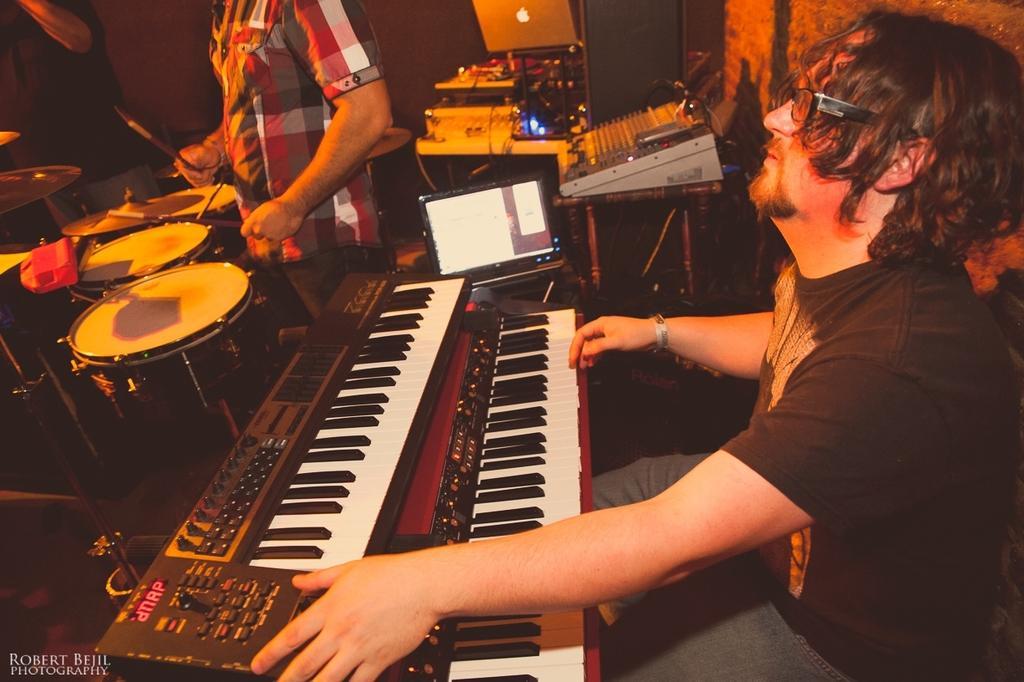Could you give a brief overview of what you see in this image? This is a picture taken in a room, the man in black t shirt sitting on a chair and playing the piano and the other man is holding a drum stick and playing the drum. Background of this two people there are music instrument on a laptop and a wall. 